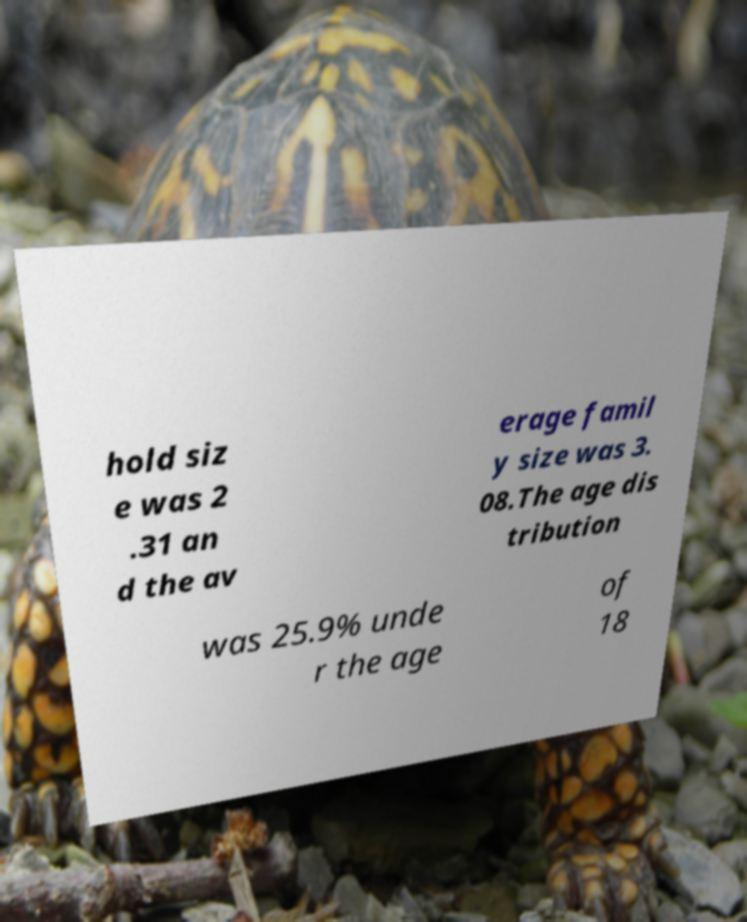I need the written content from this picture converted into text. Can you do that? hold siz e was 2 .31 an d the av erage famil y size was 3. 08.The age dis tribution was 25.9% unde r the age of 18 